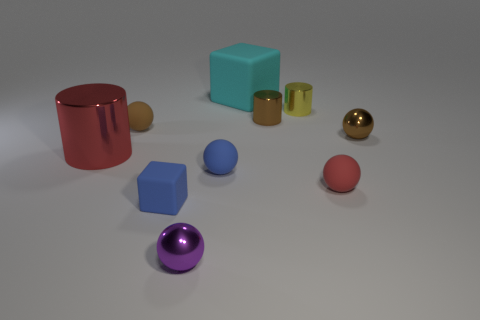Subtract all small yellow cylinders. How many cylinders are left? 2 Subtract 5 spheres. How many spheres are left? 0 Subtract all brown spheres. How many spheres are left? 3 Subtract all yellow cylinders. How many brown balls are left? 2 Subtract 0 green cylinders. How many objects are left? 10 Subtract all cylinders. How many objects are left? 7 Subtract all red balls. Subtract all brown cubes. How many balls are left? 4 Subtract all purple rubber blocks. Subtract all small shiny things. How many objects are left? 6 Add 6 small red spheres. How many small red spheres are left? 7 Add 7 large green shiny cylinders. How many large green shiny cylinders exist? 7 